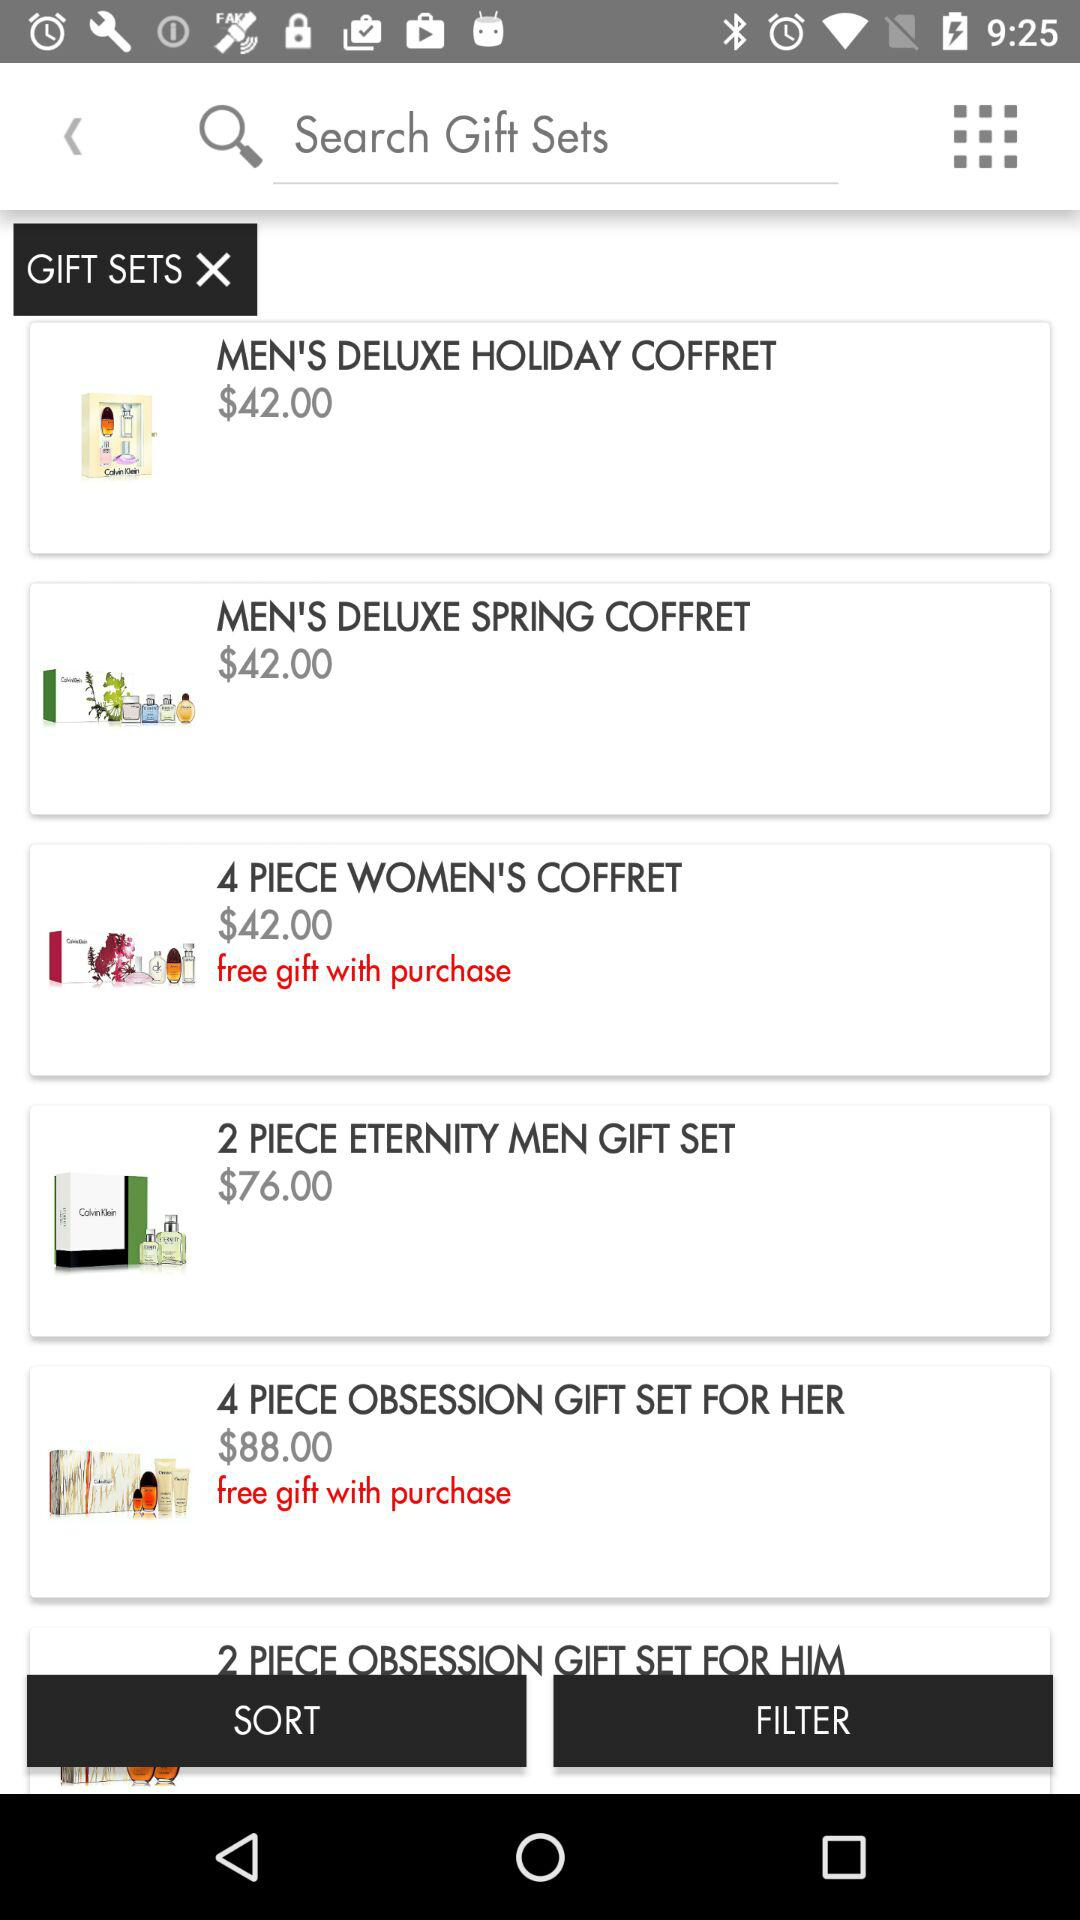How many pieces are available in the "WOMEN'S COFFRET"? There are 4 pieces available in the "WOMEN'S COFFRET". 